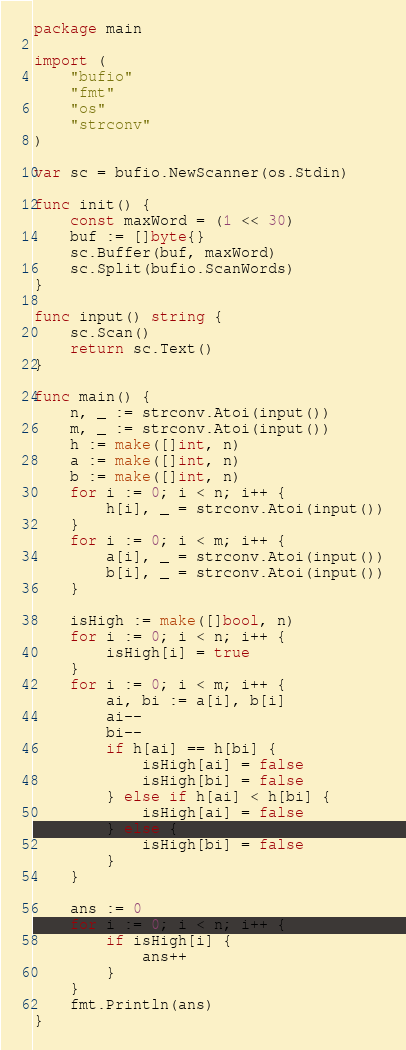Convert code to text. <code><loc_0><loc_0><loc_500><loc_500><_Go_>package main

import (
	"bufio"
	"fmt"
	"os"
	"strconv"
)

var sc = bufio.NewScanner(os.Stdin)

func init() {
	const maxWord = (1 << 30)
	buf := []byte{}
	sc.Buffer(buf, maxWord)
	sc.Split(bufio.ScanWords)
}

func input() string {
	sc.Scan()
	return sc.Text()
}

func main() {
	n, _ := strconv.Atoi(input())
	m, _ := strconv.Atoi(input())
	h := make([]int, n)
	a := make([]int, n)
	b := make([]int, n)
	for i := 0; i < n; i++ {
		h[i], _ = strconv.Atoi(input())
	}
	for i := 0; i < m; i++ {
		a[i], _ = strconv.Atoi(input())
		b[i], _ = strconv.Atoi(input())
	}

	isHigh := make([]bool, n)
	for i := 0; i < n; i++ {
		isHigh[i] = true
	}
	for i := 0; i < m; i++ {
		ai, bi := a[i], b[i]
		ai--
		bi--
		if h[ai] == h[bi] {
			isHigh[ai] = false
			isHigh[bi] = false
		} else if h[ai] < h[bi] {
			isHigh[ai] = false
		} else {
			isHigh[bi] = false
		}
	}

	ans := 0
	for i := 0; i < n; i++ {
		if isHigh[i] {
			ans++
		}
	}
	fmt.Println(ans)
}
</code> 